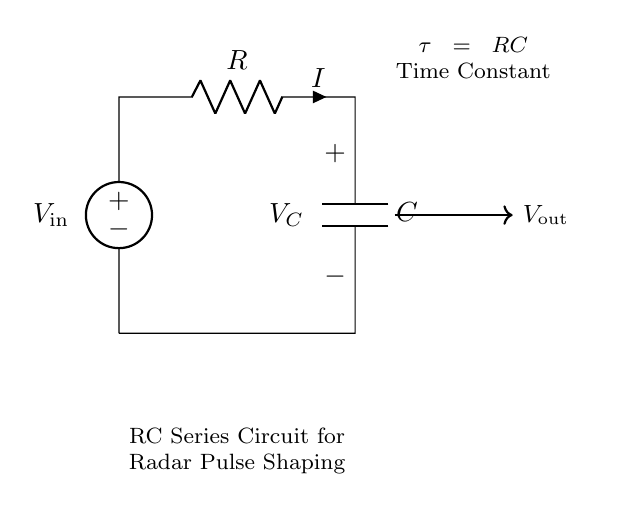What is the input voltage? The input voltage is denoted as V_in in the circuit diagram, which is the source voltage applied to the circuit.
Answer: V_in What component follows the resistor? The component that follows the resistor in the series circuit is the capacitor, as indicated by the schematic flow from the resistor to the capacitor.
Answer: C What is the time constant of the RC circuit? The time constant (τ) of the circuit is given by the product of the resistance (R) and the capacitance (C), which is a critical parameter for pulse shaping in radar applications.
Answer: τ = RC What is the relationship between current and voltage across C? In a series RC circuit, the current (I) through the resistor also flows through the capacitor; thus, the voltage across the capacitor is related to the current in that it accumulates charge over time as I charges C.
Answer: I = d(V_C)/dt What happens to V_out when the circuit is powered? When the circuit is powered, the output voltage (V_out) across the capacitor follows an exponential curve, gradually increasing and approaching V_in over time, defined by the time constant of the circuit.
Answer: Exponential rise What effect does increasing R have on pulse timing? Increasing the resistance R will increase the time constant τ, which subsequently slows down the charging and discharging curves of the capacitor, affecting how quickly pulses are shaped and timed in radar applications.
Answer: Slower timing 